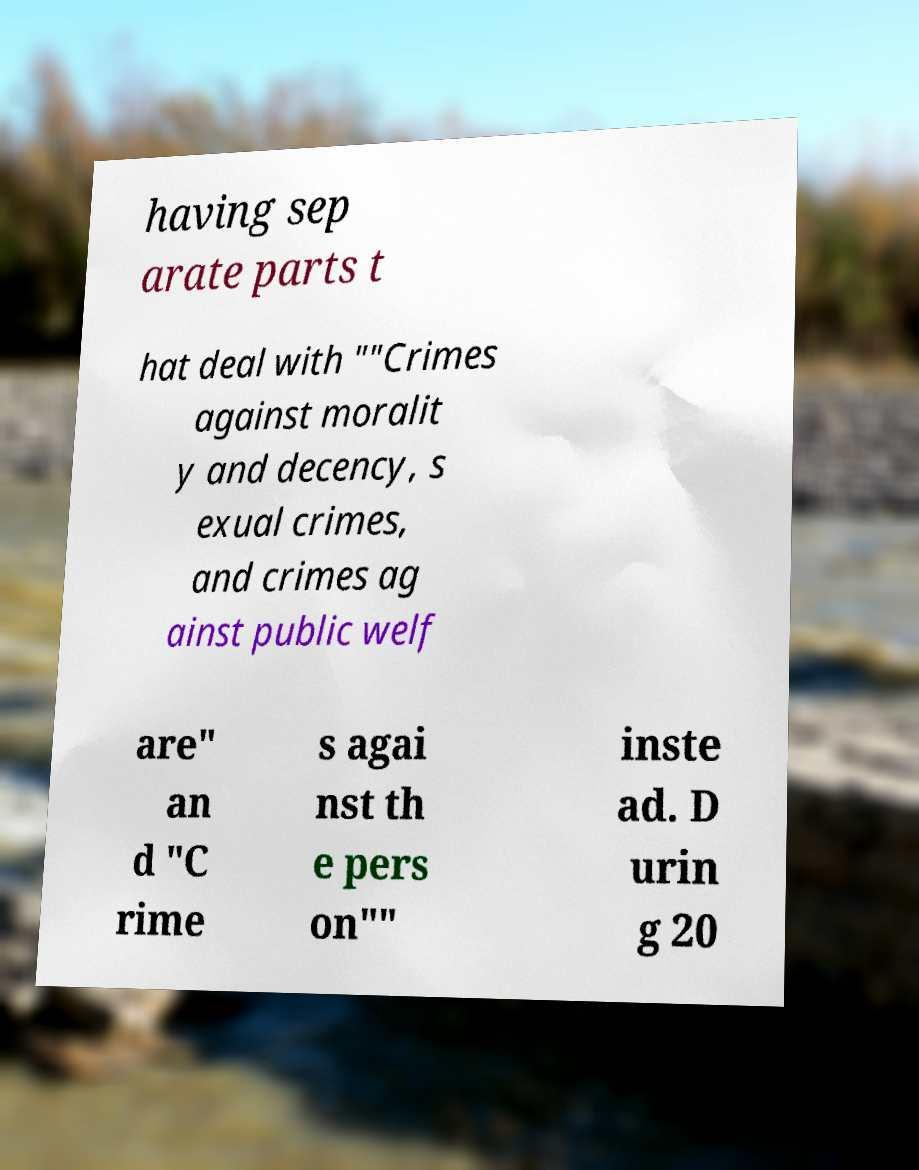For documentation purposes, I need the text within this image transcribed. Could you provide that? having sep arate parts t hat deal with ""Crimes against moralit y and decency, s exual crimes, and crimes ag ainst public welf are" an d "C rime s agai nst th e pers on"" inste ad. D urin g 20 